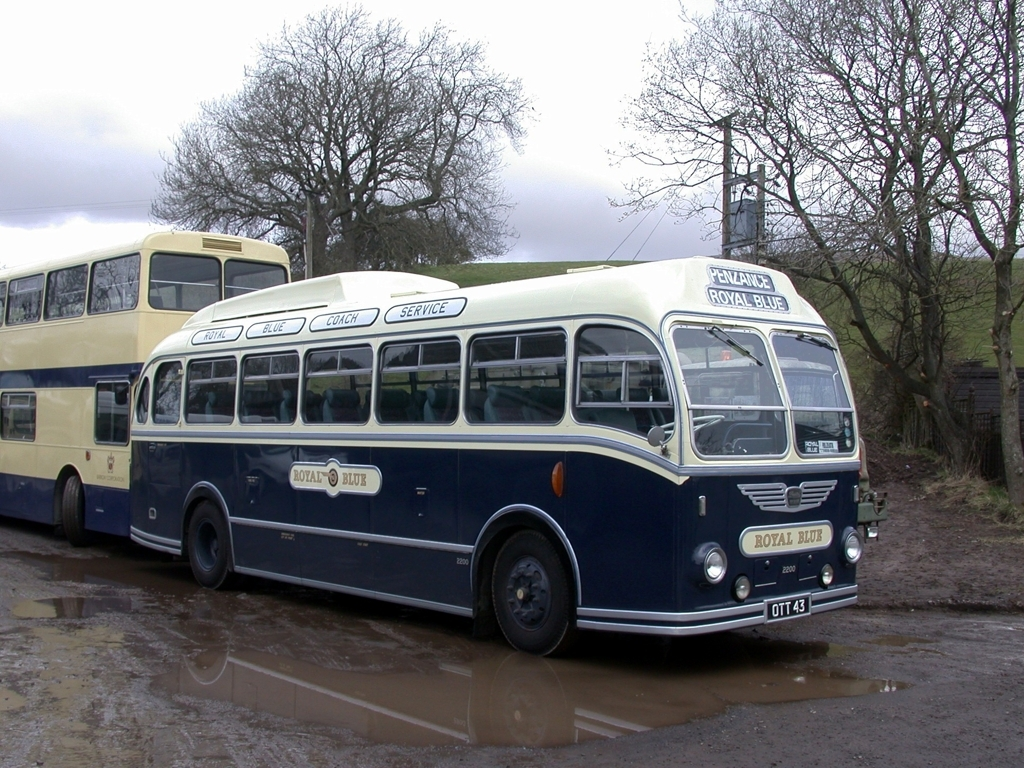What might be the historical significance of these types of buses? These buses likely hold quite a bit of historical significance as they were part of the essential transportation network during the post-war era, contributing to societal mobility and the economic revival. They also showcase the design and technological advancements of their time and are now considered classic or vintage. Would they be considered collectibles today? Absolutely, vintage buses like these are often prized by collectors and enthusiasts. They are restored and preserved with great care, often showcased at transportation museums or heritage events, celebrated for their craftsmanship and their role in the history of transportation. 